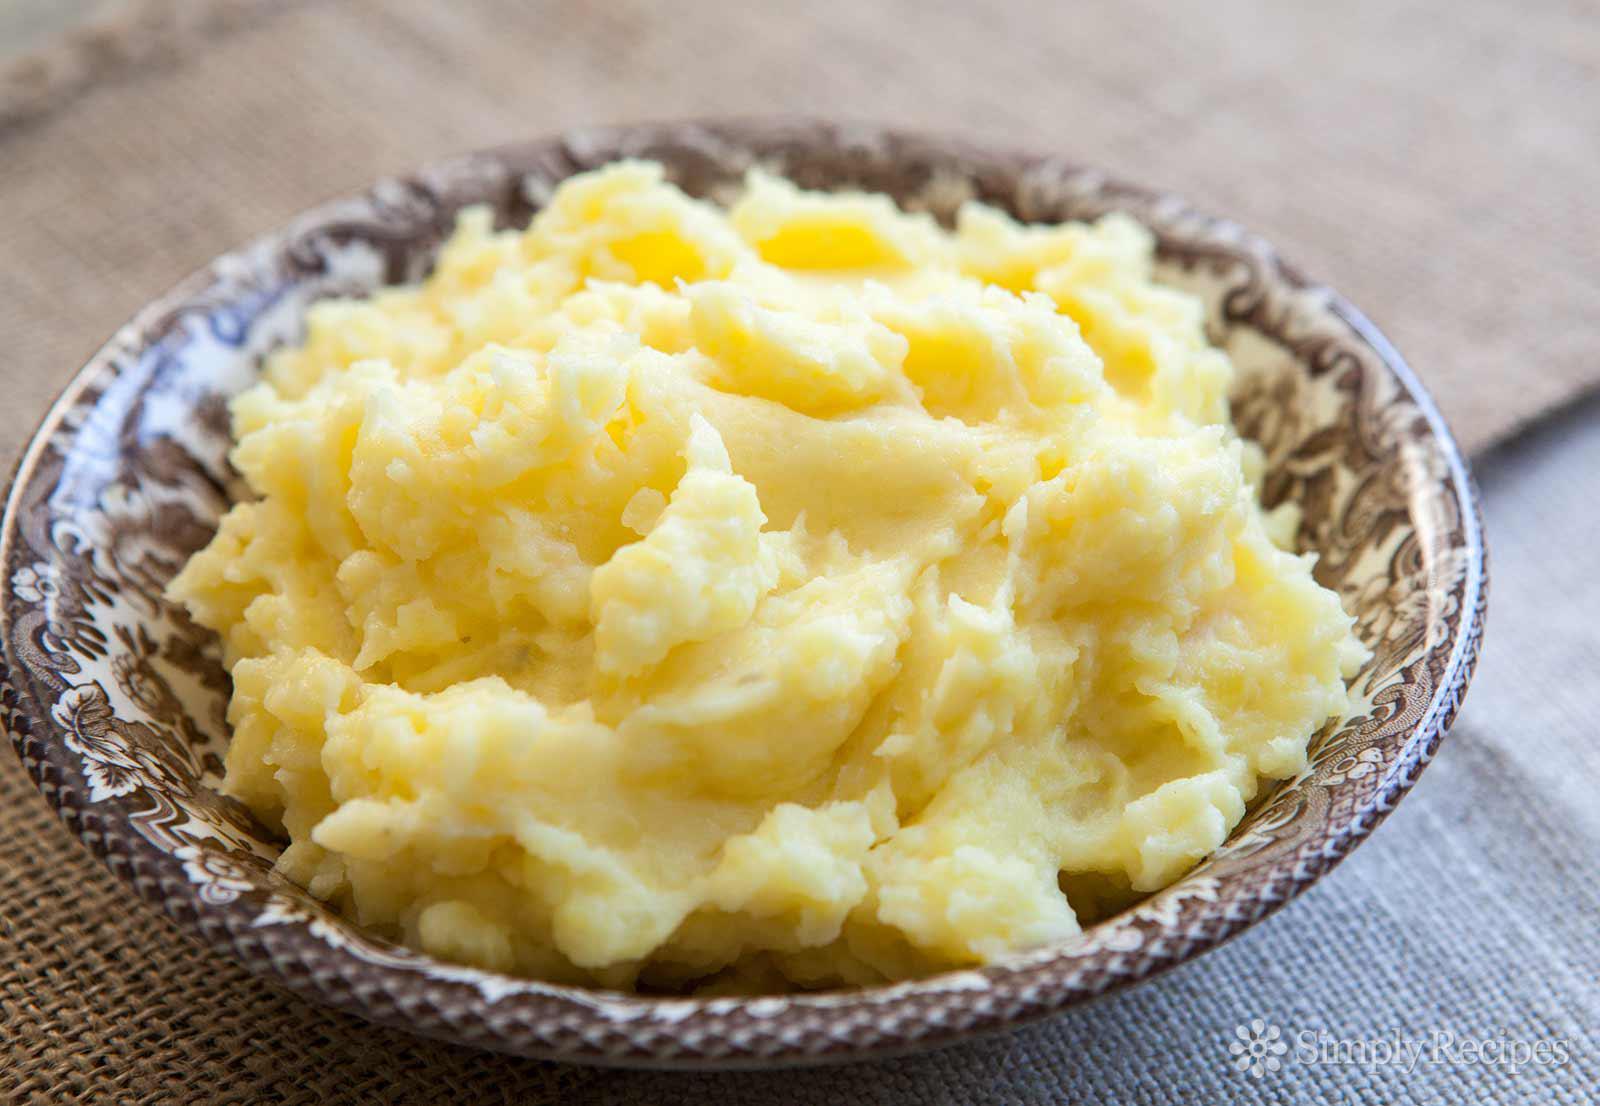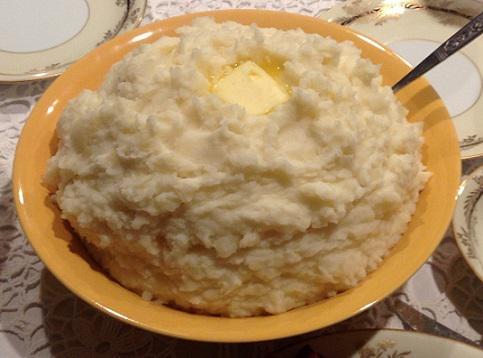The first image is the image on the left, the second image is the image on the right. For the images displayed, is the sentence "At least one serving of mashed potato is presented in clear, round glass bowl." factually correct? Answer yes or no. No. The first image is the image on the left, the second image is the image on the right. Evaluate the accuracy of this statement regarding the images: "There is an eating utensil in a bowl of mashed potatoes.". Is it true? Answer yes or no. Yes. 